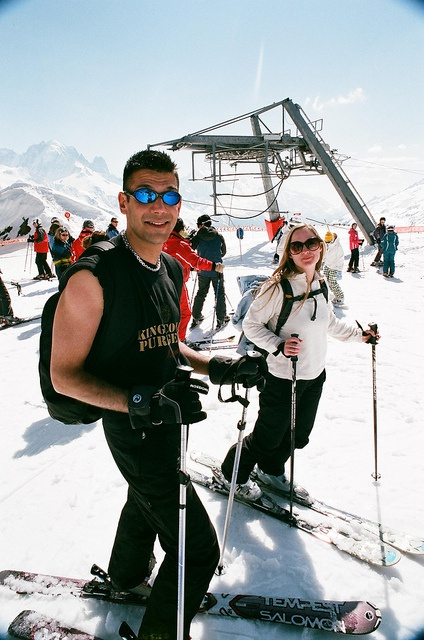Describe the objects in this image and their specific colors. I can see people in blue, black, salmon, maroon, and gray tones, people in blue, black, lightgray, and darkgray tones, skis in blue, black, lightgray, gray, and darkgray tones, skis in blue, white, black, darkgray, and gray tones, and backpack in blue, black, gray, and darkgray tones in this image. 